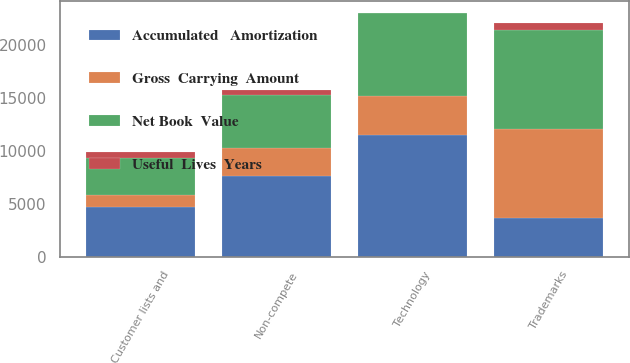Convert chart to OTSL. <chart><loc_0><loc_0><loc_500><loc_500><stacked_bar_chart><ecel><fcel>Trademarks<fcel>Customer lists and<fcel>Non-compete<fcel>Technology<nl><fcel>Useful  Lives  Years<fcel>710<fcel>510<fcel>510<fcel>3<nl><fcel>Accumulated   Amortization<fcel>3669<fcel>4673<fcel>7617<fcel>11509<nl><fcel>Net Book  Value<fcel>9328<fcel>3556<fcel>5001<fcel>7840<nl><fcel>Gross  Carrying  Amount<fcel>8388<fcel>1117<fcel>2616<fcel>3669<nl></chart> 